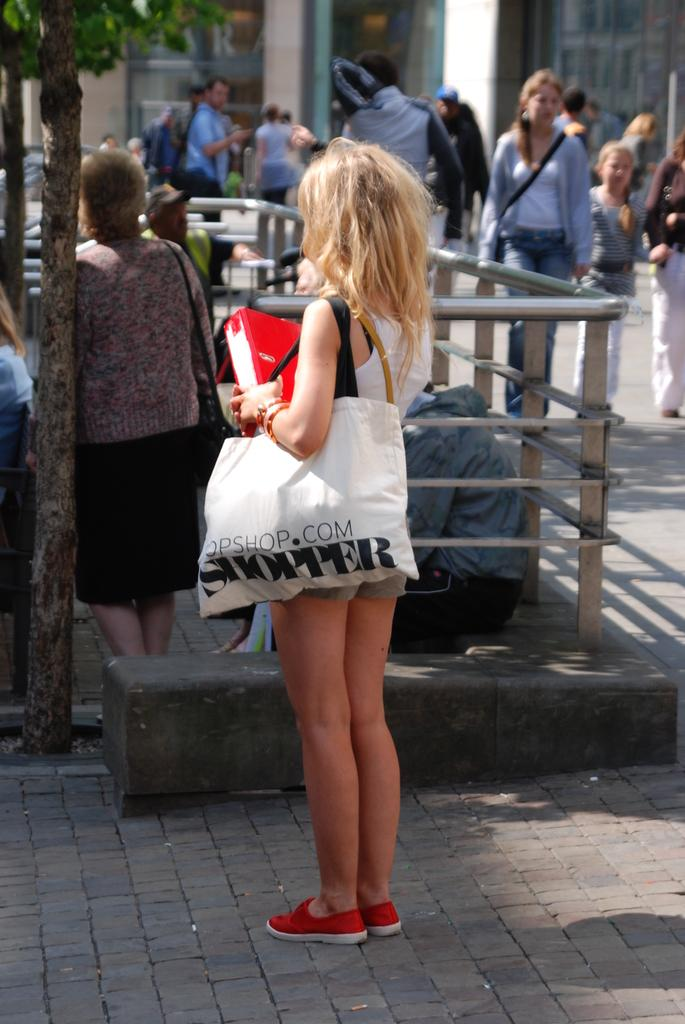<image>
Present a compact description of the photo's key features. A woman carrying a large bag with the word SHOPPER printed on it walks down a busy street. 